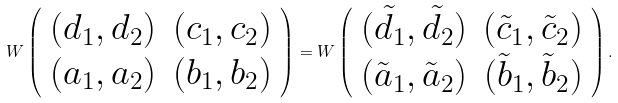<formula> <loc_0><loc_0><loc_500><loc_500>W \left ( \begin{array} { c c } { { ( d _ { 1 } , d _ { 2 } ) } } & { { ( c _ { 1 } , c _ { 2 } ) } } \\ { { ( a _ { 1 } , a _ { 2 } ) } } & { { ( b _ { 1 } , b _ { 2 } ) } } \end{array} \right ) = W \left ( \begin{array} { c c } { { ( \tilde { d } _ { 1 } , \tilde { d } _ { 2 } ) } } & { { ( \tilde { c } _ { 1 } , \tilde { c } _ { 2 } ) } } \\ { { ( \tilde { a } _ { 1 } , \tilde { a } _ { 2 } ) } } & { { ( \tilde { b } _ { 1 } , \tilde { b } _ { 2 } ) } } \end{array} \right ) .</formula> 